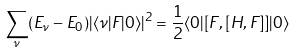Convert formula to latex. <formula><loc_0><loc_0><loc_500><loc_500>\sum _ { \nu } ( E _ { \nu } - E _ { 0 } ) | \langle \nu | F | 0 \rangle | ^ { 2 } = \frac { 1 } { 2 } \langle 0 | [ F , [ H , F ] ] | 0 \rangle</formula> 